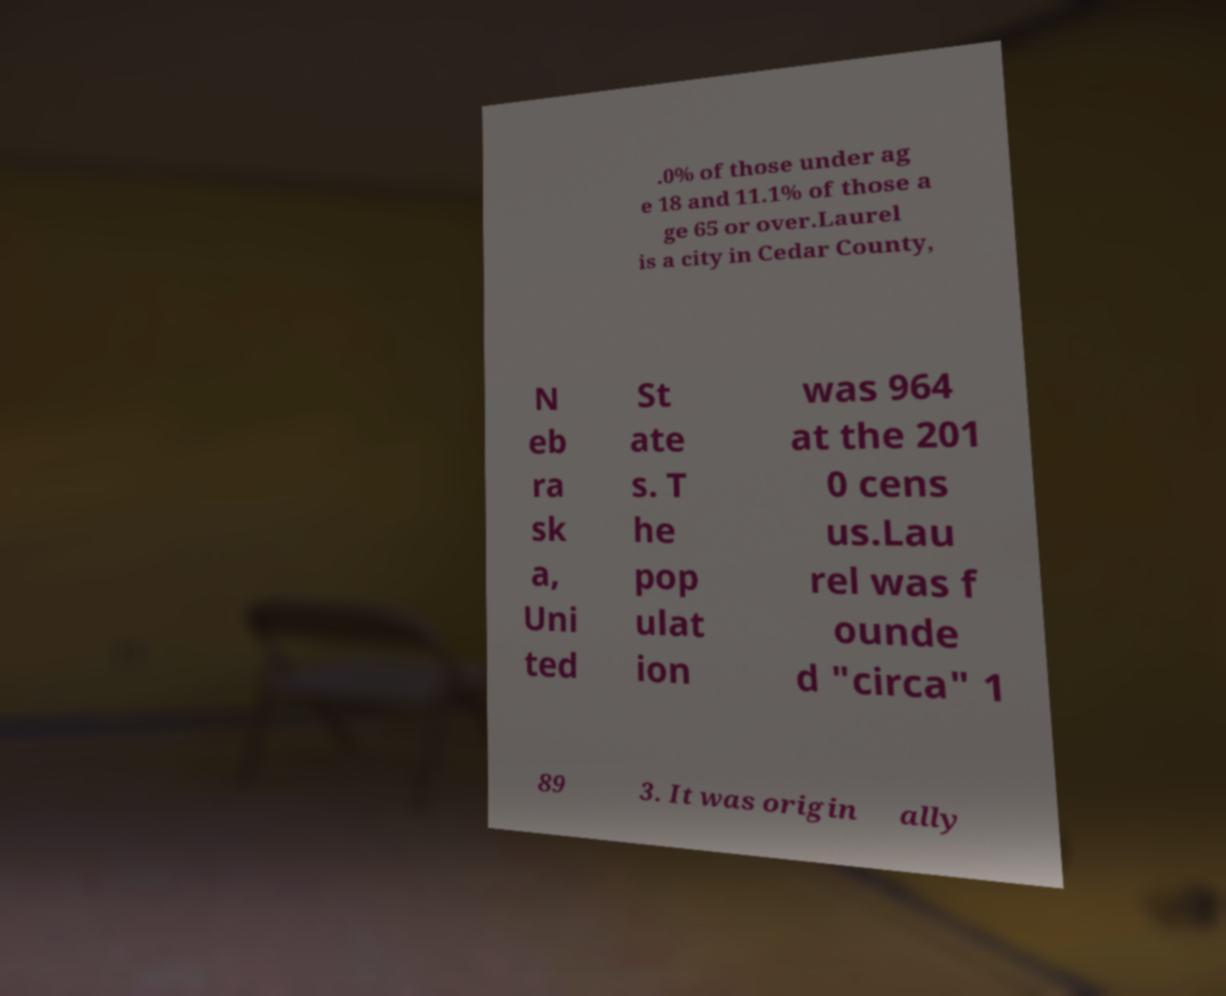Could you assist in decoding the text presented in this image and type it out clearly? .0% of those under ag e 18 and 11.1% of those a ge 65 or over.Laurel is a city in Cedar County, N eb ra sk a, Uni ted St ate s. T he pop ulat ion was 964 at the 201 0 cens us.Lau rel was f ounde d "circa" 1 89 3. It was origin ally 